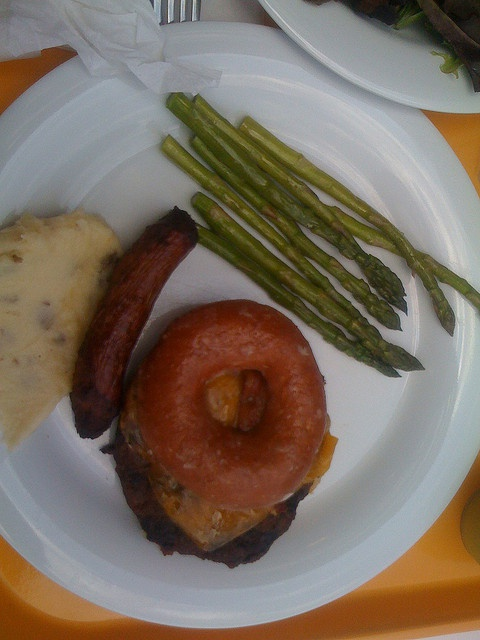Describe the objects in this image and their specific colors. I can see sandwich in gray, maroon, black, and darkgray tones, donut in gray, maroon, black, and brown tones, hot dog in gray, black, and maroon tones, and fork in gray, darkgray, and lightgray tones in this image. 